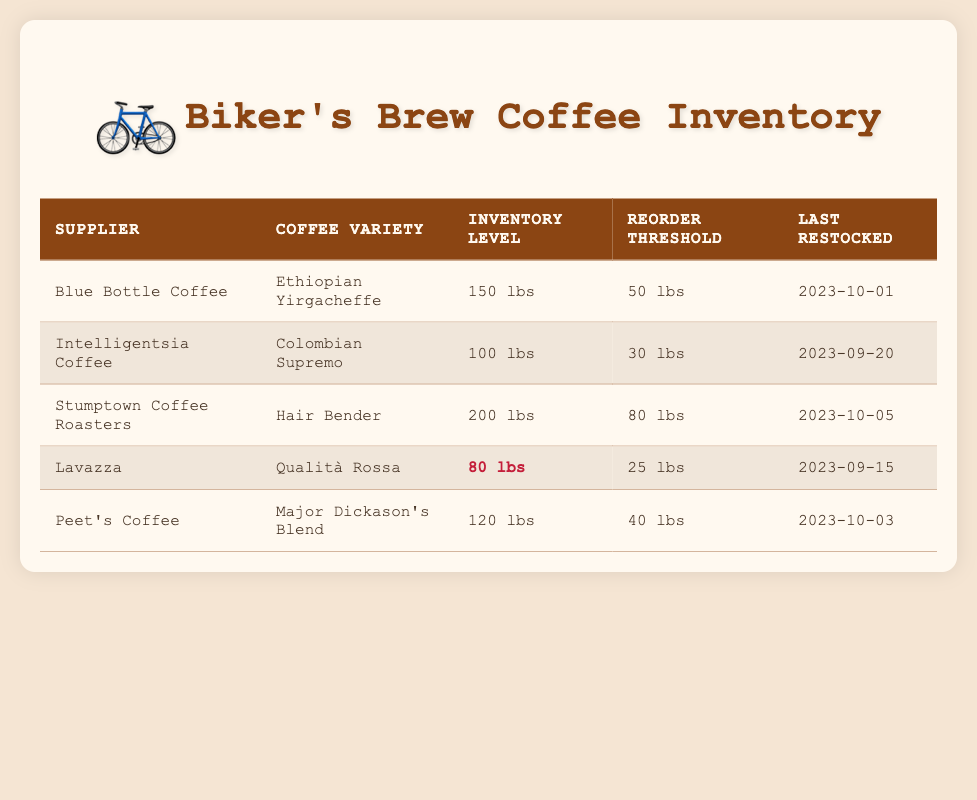What is the inventory level for Stumptown Coffee Roasters? According to the table, Stumptown Coffee Roasters has an inventory level of 200 lbs.
Answer: 200 lbs Which coffee variety from Lavazza has a reorder threshold of 25 lbs? The coffee variety from Lavazza listed in the table is Qualità Rossa, and it has a reorder threshold of 25 lbs as shown in the inventory details.
Answer: Qualità Rossa Is Blue Bottle Coffee's inventory level above its reorder threshold? Blue Bottle Coffee has an inventory level of 150 lbs, while its reorder threshold is 50 lbs. Since 150 lbs is greater than 50 lbs, the answer is yes.
Answer: Yes What is the total inventory level of all coffee varieties listed in the table? To find the total inventory level, add all the inventory levels: 150 + 100 + 200 + 80 + 120 = 650 lbs. Therefore, the total inventory level is 650 lbs.
Answer: 650 lbs Which supplier has the lowest inventory level, and what is that level? From the table, Lavazza has the lowest inventory level of 80 lbs compared to other suppliers. Therefore, Lavazza is the supplier with the lowest inventory level.
Answer: Lavazza, 80 lbs How many suppliers have an inventory level below 100 lbs? Looking at the inventory levels, only Lavazza with 80 lbs has an inventory below 100 lbs. Thus, there is 1 supplier with an inventory level below 100 lbs.
Answer: 1 If we consider only the suppliers with an inventory level below their respective reorder thresholds, how many are there? Lavazza has an inventory level of 80 lbs, which is below its reorder threshold of 25 lbs, but the others do not. Therefore, only Lavazza's inventory level is below its reorder threshold, making it 1 supplier.
Answer: 1 What is the average inventory level across all suppliers? The total inventory is 650 lbs and there are 5 suppliers. To find the average, divide the total by the number of suppliers: 650 lbs / 5 = 130 lbs. The average inventory level across all suppliers is 130 lbs.
Answer: 130 lbs Which supplier was last restocked on 2023-10-05? According to the table, Stumptown Coffee Roasters was last restocked on 2023-10-05.
Answer: Stumptown Coffee Roasters 